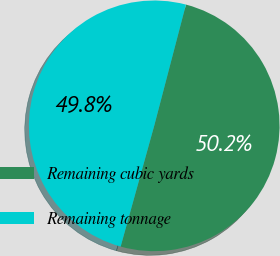Convert chart to OTSL. <chart><loc_0><loc_0><loc_500><loc_500><pie_chart><fcel>Remaining cubic yards<fcel>Remaining tonnage<nl><fcel>50.24%<fcel>49.76%<nl></chart> 